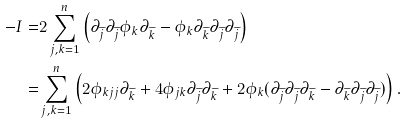Convert formula to latex. <formula><loc_0><loc_0><loc_500><loc_500>- I = & 2 \sum _ { j , k = 1 } ^ { n } \left ( \partial _ { \widetilde { j } } \partial _ { \widetilde { j } } \phi _ { k } \partial _ { \widetilde { k } } - \phi _ { k } \partial _ { \widetilde { k } } \partial _ { \widetilde { j } } \partial _ { \widetilde { j } } \right ) \\ = & \sum _ { j , k = 1 } ^ { n } \left ( 2 \phi _ { k j j } \partial _ { \widetilde { k } } + 4 \phi _ { j k } \partial _ { \widetilde { j } } \partial _ { \widetilde { k } } + 2 \phi _ { k } ( \partial _ { \widetilde { j } } \partial _ { \widetilde { j } } \partial _ { \widetilde { k } } - \partial _ { \widetilde { k } } \partial _ { \widetilde { j } } \partial _ { \widetilde { j } } ) \right ) .</formula> 